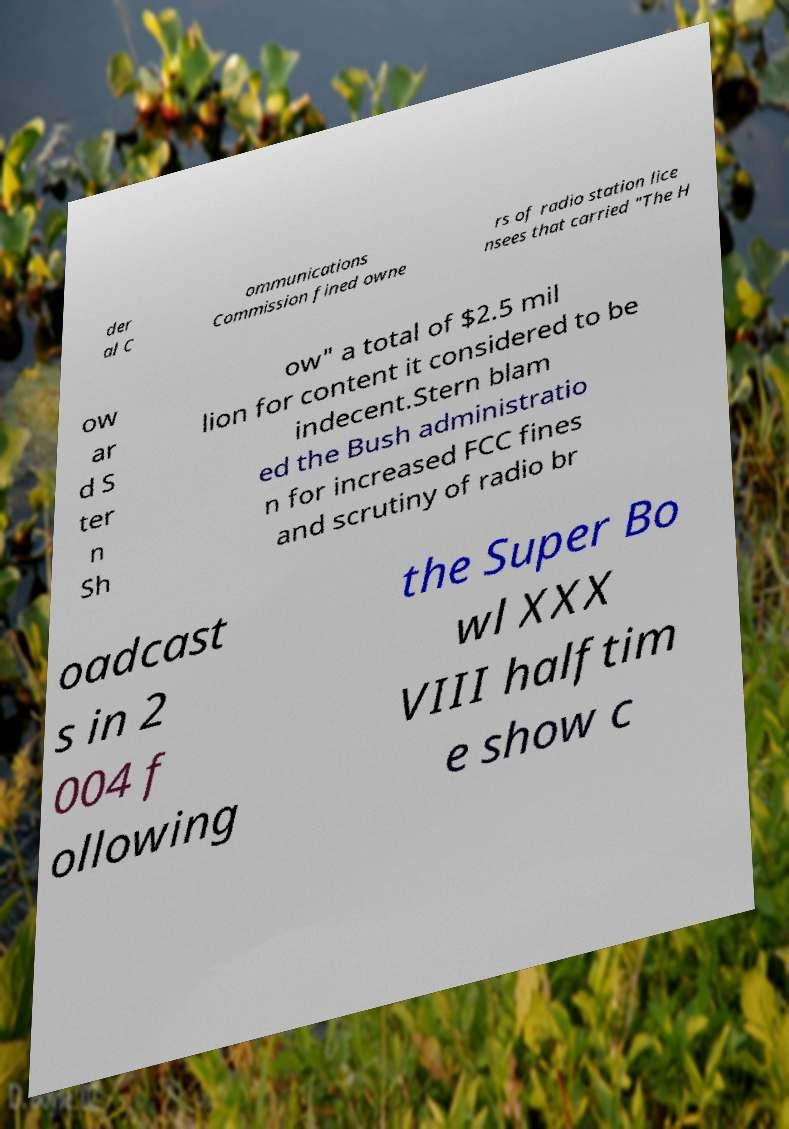What messages or text are displayed in this image? I need them in a readable, typed format. der al C ommunications Commission fined owne rs of radio station lice nsees that carried "The H ow ar d S ter n Sh ow" a total of $2.5 mil lion for content it considered to be indecent.Stern blam ed the Bush administratio n for increased FCC fines and scrutiny of radio br oadcast s in 2 004 f ollowing the Super Bo wl XXX VIII halftim e show c 